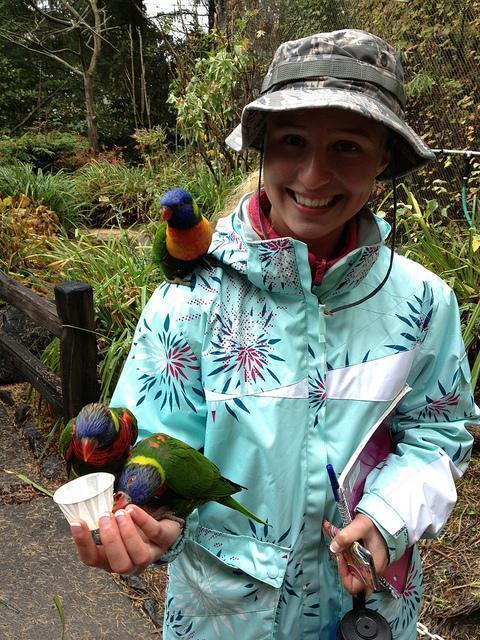What color is the rain jacket worn by the woman in the rainforest?
Answer the question by selecting the correct answer among the 4 following choices and explain your choice with a short sentence. The answer should be formatted with the following format: `Answer: choice
Rationale: rationale.`
Options: Red, purple, teal, orange. Answer: teal.
Rationale: Her rainjacket is not purple, red, or orange. 